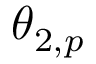<formula> <loc_0><loc_0><loc_500><loc_500>\theta _ { 2 , p }</formula> 